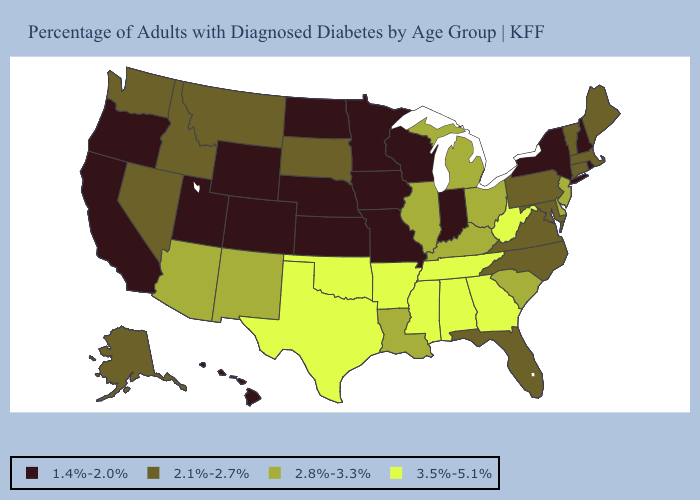What is the value of Georgia?
Short answer required. 3.5%-5.1%. Does New Jersey have the highest value in the Northeast?
Concise answer only. Yes. What is the value of Kentucky?
Write a very short answer. 2.8%-3.3%. What is the highest value in the Northeast ?
Short answer required. 2.8%-3.3%. Does New Mexico have the lowest value in the USA?
Answer briefly. No. Does New Mexico have a lower value than Texas?
Be succinct. Yes. What is the value of New York?
Be succinct. 1.4%-2.0%. What is the value of Kentucky?
Answer briefly. 2.8%-3.3%. Which states have the lowest value in the USA?
Concise answer only. California, Colorado, Hawaii, Indiana, Iowa, Kansas, Minnesota, Missouri, Nebraska, New Hampshire, New York, North Dakota, Oregon, Rhode Island, Utah, Wisconsin, Wyoming. Name the states that have a value in the range 1.4%-2.0%?
Write a very short answer. California, Colorado, Hawaii, Indiana, Iowa, Kansas, Minnesota, Missouri, Nebraska, New Hampshire, New York, North Dakota, Oregon, Rhode Island, Utah, Wisconsin, Wyoming. What is the value of Colorado?
Answer briefly. 1.4%-2.0%. What is the lowest value in the West?
Concise answer only. 1.4%-2.0%. Name the states that have a value in the range 2.1%-2.7%?
Concise answer only. Alaska, Connecticut, Florida, Idaho, Maine, Maryland, Massachusetts, Montana, Nevada, North Carolina, Pennsylvania, South Dakota, Vermont, Virginia, Washington. What is the value of Washington?
Quick response, please. 2.1%-2.7%. What is the value of Indiana?
Be succinct. 1.4%-2.0%. 